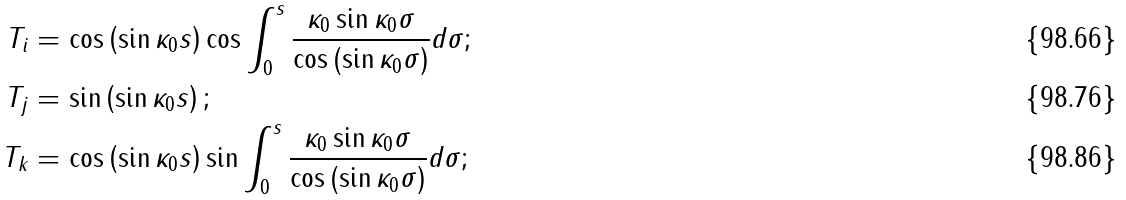Convert formula to latex. <formula><loc_0><loc_0><loc_500><loc_500>T _ { i } & = \cos \left ( \sin \kappa _ { 0 } s \right ) \cos \int _ { 0 } ^ { s } \frac { \kappa _ { 0 } \sin \kappa _ { 0 } \sigma } { \cos \left ( \sin \kappa _ { 0 } \sigma \right ) } d \sigma ; \\ T _ { j } & = \sin \left ( \sin \kappa _ { 0 } s \right ) ; \\ T _ { k } & = \cos \left ( \sin \kappa _ { 0 } s \right ) \sin \int _ { 0 } ^ { s } \frac { \kappa _ { 0 } \sin \kappa _ { 0 } \sigma } { \cos \left ( \sin \kappa _ { 0 } \sigma \right ) } d \sigma ;</formula> 